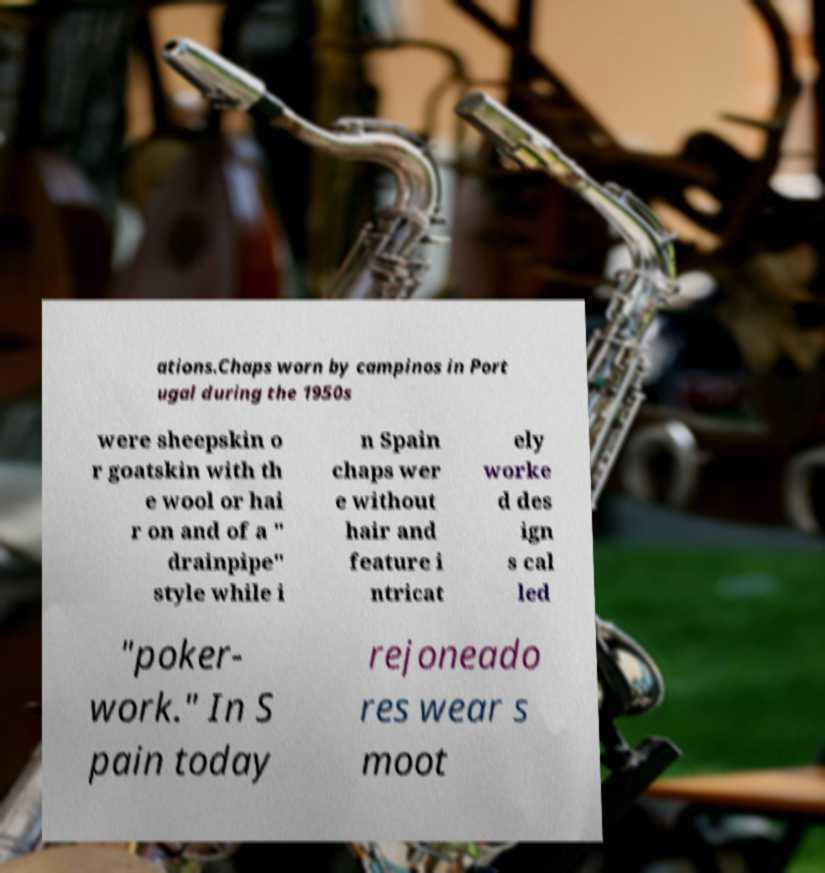Could you assist in decoding the text presented in this image and type it out clearly? ations.Chaps worn by campinos in Port ugal during the 1950s were sheepskin o r goatskin with th e wool or hai r on and of a " drainpipe" style while i n Spain chaps wer e without hair and feature i ntricat ely worke d des ign s cal led "poker- work." In S pain today rejoneado res wear s moot 